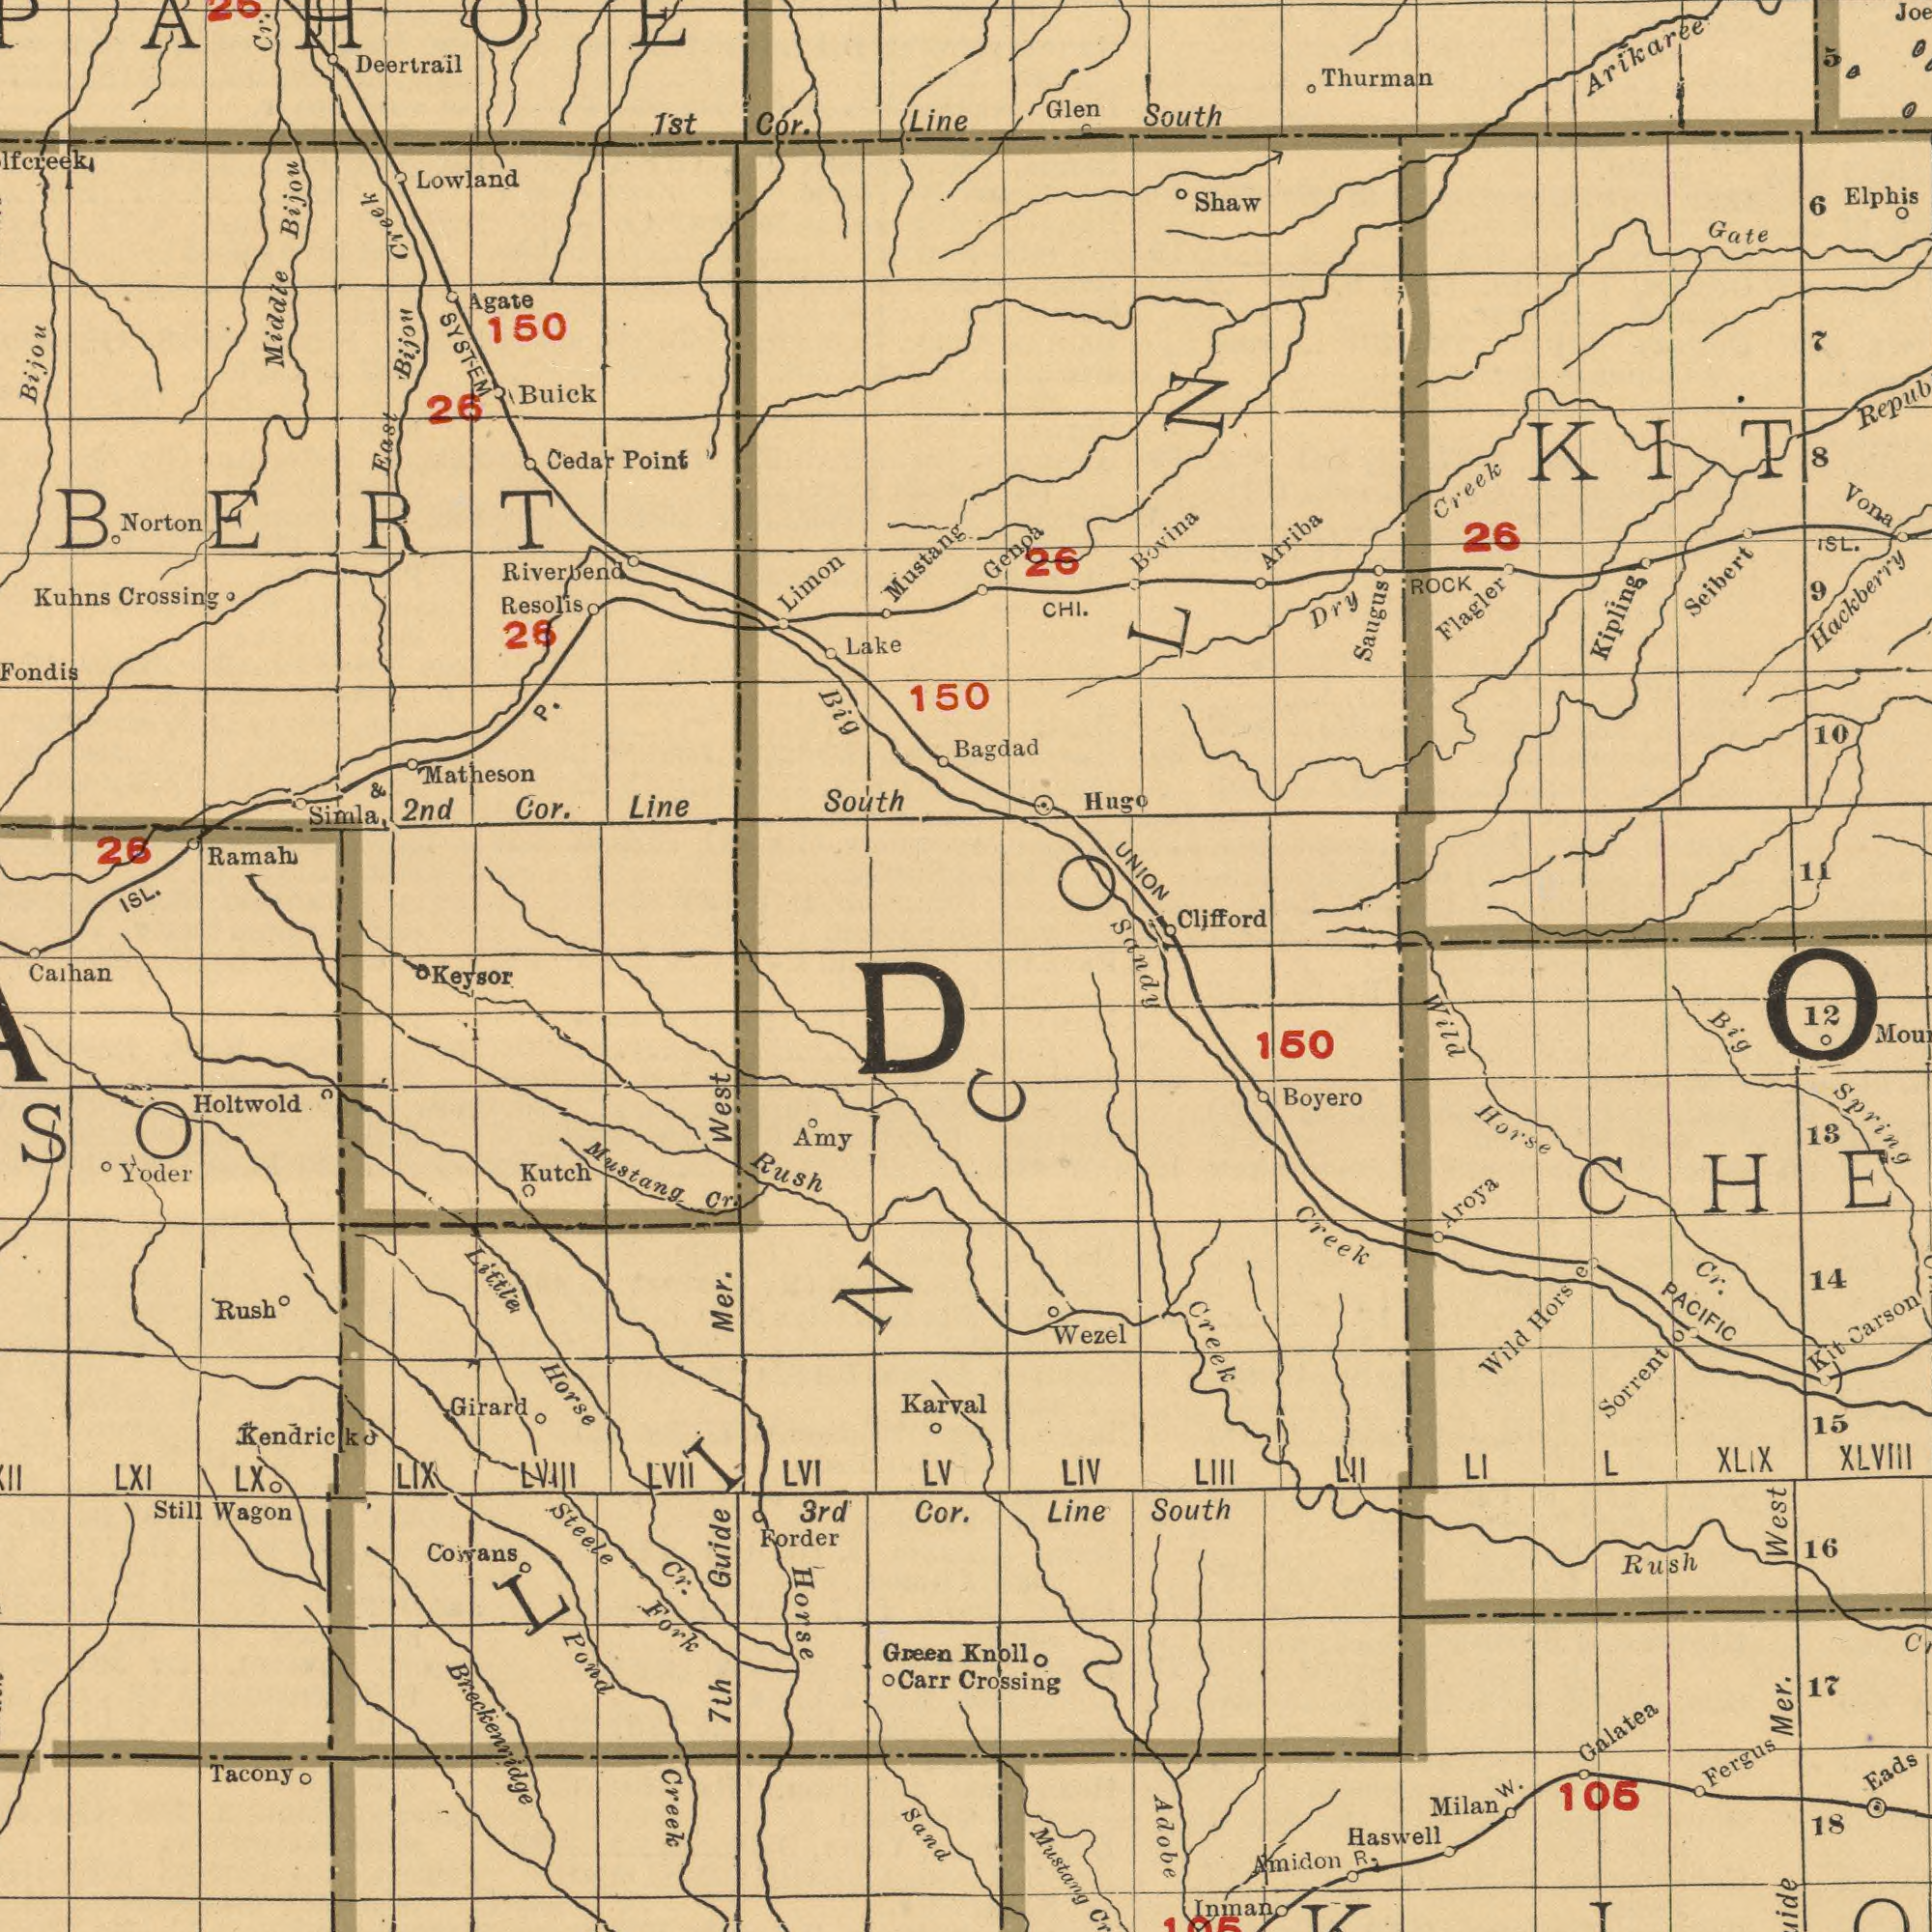What text appears in the bottom-right area of the image? Mustang Wild Adobe Creek Creek Fergus Rush Mer. Eads Sorrent Amidon XLIX West Galatea 16 Hors PACIFIC Boyero Cr. Line Horse XLVlII Carson South Milan W. Inman 18 Wezel Haswell Crossing Wild 13 LIV Aroya 14 15 12 Spring 106 LIII R. 17 LI 150 Kit L Knoll LII Big o LINCOLN e What text can you see in the bottom-left section? Breckenridge Mustang Horse Holtwold Fork West Cowans 7th Amy Carr Little LXI Rush LVII Girard Karval Wagon Cr. Mer. Calhan Yoder LIX LVI Steele Green Forder 3rd Tacony Rush LVIll LV Pond Cor. Kendrick Horse Still Cr. Sand Guide Kutch LX Creek Keysor What text is shown in the top-left quadrant? Bijou Riverbend Ramah Kuhns Deertrail Middle Matheson Cor. South Lake 1st ISL. Limon Lowland Cr. 150 Crossing Buick 2nd SYSTEM Cor. Resolis Line Simla Fondis Bijou Cedar Point Mustang Line East 26 26 P. 26 Bijou Big Agate & 150 Creek Norton ###BERT creek What text is shown in the top-right quadrant? Arikaree Seibert Hugo Saugus UNION Flagler 26 Creek 10 Hackberry Elphis Arriba Shaw Gate Dry Vona Bovina ISL. Glen ROCK Kipling 6 26 CHI. Clifford 9 11 South Bagdad Genoa Thurman Sandy 8 5 7 